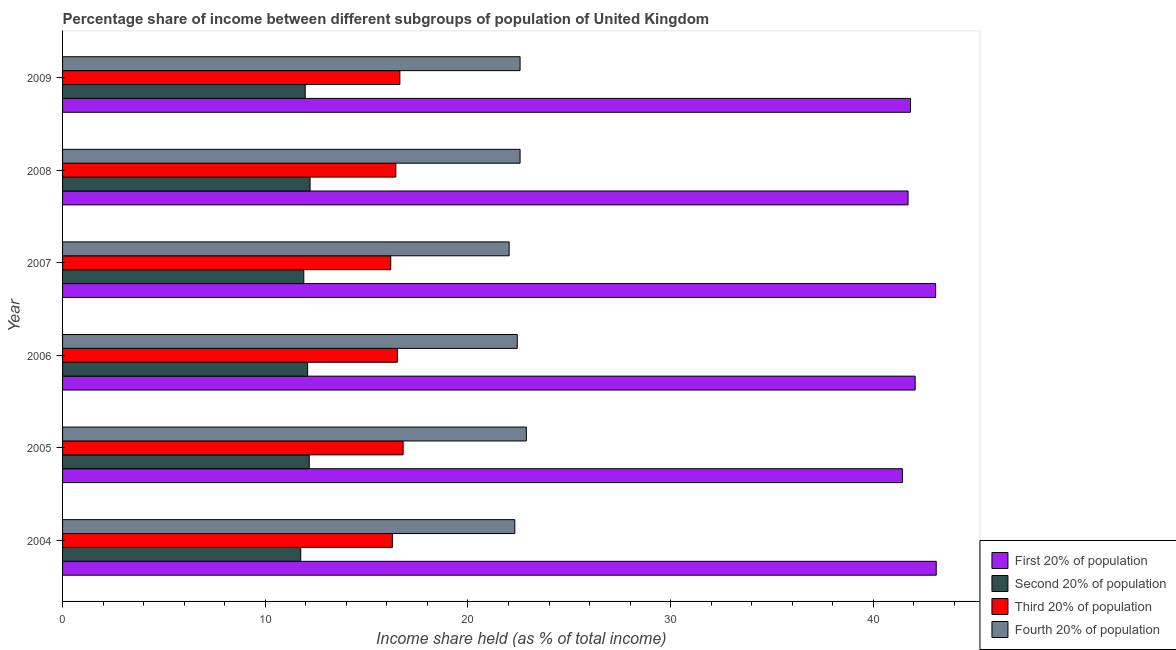Are the number of bars per tick equal to the number of legend labels?
Make the answer very short. Yes. What is the share of the income held by second 20% of the population in 2007?
Your answer should be very brief. 11.9. Across all years, what is the maximum share of the income held by second 20% of the population?
Your answer should be very brief. 12.21. Across all years, what is the minimum share of the income held by first 20% of the population?
Give a very brief answer. 41.43. In which year was the share of the income held by fourth 20% of the population maximum?
Your answer should be compact. 2005. In which year was the share of the income held by fourth 20% of the population minimum?
Offer a very short reply. 2007. What is the total share of the income held by third 20% of the population in the graph?
Offer a terse response. 98.86. What is the difference between the share of the income held by third 20% of the population in 2005 and that in 2007?
Ensure brevity in your answer.  0.61. What is the difference between the share of the income held by first 20% of the population in 2009 and the share of the income held by fourth 20% of the population in 2007?
Give a very brief answer. 19.8. What is the average share of the income held by fourth 20% of the population per year?
Offer a terse response. 22.46. In how many years, is the share of the income held by fourth 20% of the population greater than 34 %?
Provide a succinct answer. 0. What is the ratio of the share of the income held by third 20% of the population in 2006 to that in 2007?
Provide a short and direct response. 1.02. Is the share of the income held by fourth 20% of the population in 2006 less than that in 2007?
Provide a succinct answer. No. What is the difference between the highest and the second highest share of the income held by fourth 20% of the population?
Make the answer very short. 0.31. In how many years, is the share of the income held by third 20% of the population greater than the average share of the income held by third 20% of the population taken over all years?
Ensure brevity in your answer.  3. Is the sum of the share of the income held by fourth 20% of the population in 2005 and 2008 greater than the maximum share of the income held by first 20% of the population across all years?
Keep it short and to the point. Yes. Is it the case that in every year, the sum of the share of the income held by third 20% of the population and share of the income held by first 20% of the population is greater than the sum of share of the income held by second 20% of the population and share of the income held by fourth 20% of the population?
Your answer should be compact. Yes. What does the 4th bar from the top in 2006 represents?
Ensure brevity in your answer.  First 20% of population. What does the 2nd bar from the bottom in 2009 represents?
Make the answer very short. Second 20% of population. Is it the case that in every year, the sum of the share of the income held by first 20% of the population and share of the income held by second 20% of the population is greater than the share of the income held by third 20% of the population?
Offer a terse response. Yes. How many bars are there?
Provide a short and direct response. 24. Are all the bars in the graph horizontal?
Your response must be concise. Yes. How many years are there in the graph?
Your answer should be very brief. 6. Are the values on the major ticks of X-axis written in scientific E-notation?
Offer a very short reply. No. Does the graph contain grids?
Make the answer very short. No. Where does the legend appear in the graph?
Offer a terse response. Bottom right. How many legend labels are there?
Give a very brief answer. 4. What is the title of the graph?
Your answer should be very brief. Percentage share of income between different subgroups of population of United Kingdom. What is the label or title of the X-axis?
Your answer should be compact. Income share held (as % of total income). What is the label or title of the Y-axis?
Offer a terse response. Year. What is the Income share held (as % of total income) in First 20% of population in 2004?
Make the answer very short. 43.1. What is the Income share held (as % of total income) of Second 20% of population in 2004?
Make the answer very short. 11.75. What is the Income share held (as % of total income) in Third 20% of population in 2004?
Make the answer very short. 16.27. What is the Income share held (as % of total income) of Fourth 20% of population in 2004?
Give a very brief answer. 22.31. What is the Income share held (as % of total income) of First 20% of population in 2005?
Offer a terse response. 41.43. What is the Income share held (as % of total income) of Second 20% of population in 2005?
Give a very brief answer. 12.17. What is the Income share held (as % of total income) of Fourth 20% of population in 2005?
Your response must be concise. 22.88. What is the Income share held (as % of total income) of First 20% of population in 2006?
Give a very brief answer. 42.06. What is the Income share held (as % of total income) in Second 20% of population in 2006?
Ensure brevity in your answer.  12.09. What is the Income share held (as % of total income) in Third 20% of population in 2006?
Offer a terse response. 16.52. What is the Income share held (as % of total income) in Fourth 20% of population in 2006?
Offer a very short reply. 22.43. What is the Income share held (as % of total income) in First 20% of population in 2007?
Give a very brief answer. 43.07. What is the Income share held (as % of total income) in Second 20% of population in 2007?
Offer a terse response. 11.9. What is the Income share held (as % of total income) in Third 20% of population in 2007?
Give a very brief answer. 16.19. What is the Income share held (as % of total income) of Fourth 20% of population in 2007?
Ensure brevity in your answer.  22.03. What is the Income share held (as % of total income) of First 20% of population in 2008?
Offer a terse response. 41.71. What is the Income share held (as % of total income) in Second 20% of population in 2008?
Make the answer very short. 12.21. What is the Income share held (as % of total income) of Third 20% of population in 2008?
Your answer should be compact. 16.44. What is the Income share held (as % of total income) of Fourth 20% of population in 2008?
Offer a terse response. 22.57. What is the Income share held (as % of total income) of First 20% of population in 2009?
Your answer should be compact. 41.83. What is the Income share held (as % of total income) in Second 20% of population in 2009?
Offer a terse response. 11.97. What is the Income share held (as % of total income) in Third 20% of population in 2009?
Give a very brief answer. 16.64. What is the Income share held (as % of total income) of Fourth 20% of population in 2009?
Provide a short and direct response. 22.57. Across all years, what is the maximum Income share held (as % of total income) of First 20% of population?
Your response must be concise. 43.1. Across all years, what is the maximum Income share held (as % of total income) of Second 20% of population?
Give a very brief answer. 12.21. Across all years, what is the maximum Income share held (as % of total income) in Fourth 20% of population?
Provide a short and direct response. 22.88. Across all years, what is the minimum Income share held (as % of total income) of First 20% of population?
Offer a terse response. 41.43. Across all years, what is the minimum Income share held (as % of total income) in Second 20% of population?
Provide a succinct answer. 11.75. Across all years, what is the minimum Income share held (as % of total income) in Third 20% of population?
Your answer should be very brief. 16.19. Across all years, what is the minimum Income share held (as % of total income) of Fourth 20% of population?
Your answer should be very brief. 22.03. What is the total Income share held (as % of total income) of First 20% of population in the graph?
Give a very brief answer. 253.2. What is the total Income share held (as % of total income) in Second 20% of population in the graph?
Provide a succinct answer. 72.09. What is the total Income share held (as % of total income) in Third 20% of population in the graph?
Keep it short and to the point. 98.86. What is the total Income share held (as % of total income) in Fourth 20% of population in the graph?
Your answer should be very brief. 134.79. What is the difference between the Income share held (as % of total income) of First 20% of population in 2004 and that in 2005?
Offer a very short reply. 1.67. What is the difference between the Income share held (as % of total income) in Second 20% of population in 2004 and that in 2005?
Provide a succinct answer. -0.42. What is the difference between the Income share held (as % of total income) of Third 20% of population in 2004 and that in 2005?
Provide a succinct answer. -0.53. What is the difference between the Income share held (as % of total income) in Fourth 20% of population in 2004 and that in 2005?
Offer a very short reply. -0.57. What is the difference between the Income share held (as % of total income) of First 20% of population in 2004 and that in 2006?
Offer a terse response. 1.04. What is the difference between the Income share held (as % of total income) in Second 20% of population in 2004 and that in 2006?
Your response must be concise. -0.34. What is the difference between the Income share held (as % of total income) of Third 20% of population in 2004 and that in 2006?
Offer a very short reply. -0.25. What is the difference between the Income share held (as % of total income) in Fourth 20% of population in 2004 and that in 2006?
Offer a terse response. -0.12. What is the difference between the Income share held (as % of total income) in Second 20% of population in 2004 and that in 2007?
Offer a very short reply. -0.15. What is the difference between the Income share held (as % of total income) of Fourth 20% of population in 2004 and that in 2007?
Offer a very short reply. 0.28. What is the difference between the Income share held (as % of total income) of First 20% of population in 2004 and that in 2008?
Keep it short and to the point. 1.39. What is the difference between the Income share held (as % of total income) of Second 20% of population in 2004 and that in 2008?
Make the answer very short. -0.46. What is the difference between the Income share held (as % of total income) in Third 20% of population in 2004 and that in 2008?
Make the answer very short. -0.17. What is the difference between the Income share held (as % of total income) of Fourth 20% of population in 2004 and that in 2008?
Ensure brevity in your answer.  -0.26. What is the difference between the Income share held (as % of total income) of First 20% of population in 2004 and that in 2009?
Give a very brief answer. 1.27. What is the difference between the Income share held (as % of total income) of Second 20% of population in 2004 and that in 2009?
Make the answer very short. -0.22. What is the difference between the Income share held (as % of total income) in Third 20% of population in 2004 and that in 2009?
Offer a terse response. -0.37. What is the difference between the Income share held (as % of total income) of Fourth 20% of population in 2004 and that in 2009?
Your answer should be very brief. -0.26. What is the difference between the Income share held (as % of total income) in First 20% of population in 2005 and that in 2006?
Make the answer very short. -0.63. What is the difference between the Income share held (as % of total income) in Third 20% of population in 2005 and that in 2006?
Keep it short and to the point. 0.28. What is the difference between the Income share held (as % of total income) of Fourth 20% of population in 2005 and that in 2006?
Provide a short and direct response. 0.45. What is the difference between the Income share held (as % of total income) in First 20% of population in 2005 and that in 2007?
Make the answer very short. -1.64. What is the difference between the Income share held (as % of total income) in Second 20% of population in 2005 and that in 2007?
Give a very brief answer. 0.27. What is the difference between the Income share held (as % of total income) of Third 20% of population in 2005 and that in 2007?
Keep it short and to the point. 0.61. What is the difference between the Income share held (as % of total income) in Fourth 20% of population in 2005 and that in 2007?
Offer a terse response. 0.85. What is the difference between the Income share held (as % of total income) of First 20% of population in 2005 and that in 2008?
Offer a very short reply. -0.28. What is the difference between the Income share held (as % of total income) of Second 20% of population in 2005 and that in 2008?
Offer a very short reply. -0.04. What is the difference between the Income share held (as % of total income) in Third 20% of population in 2005 and that in 2008?
Provide a short and direct response. 0.36. What is the difference between the Income share held (as % of total income) in Fourth 20% of population in 2005 and that in 2008?
Give a very brief answer. 0.31. What is the difference between the Income share held (as % of total income) of First 20% of population in 2005 and that in 2009?
Offer a terse response. -0.4. What is the difference between the Income share held (as % of total income) in Third 20% of population in 2005 and that in 2009?
Give a very brief answer. 0.16. What is the difference between the Income share held (as % of total income) in Fourth 20% of population in 2005 and that in 2009?
Provide a succinct answer. 0.31. What is the difference between the Income share held (as % of total income) of First 20% of population in 2006 and that in 2007?
Ensure brevity in your answer.  -1.01. What is the difference between the Income share held (as % of total income) of Second 20% of population in 2006 and that in 2007?
Your answer should be very brief. 0.19. What is the difference between the Income share held (as % of total income) in Third 20% of population in 2006 and that in 2007?
Your answer should be very brief. 0.33. What is the difference between the Income share held (as % of total income) in Fourth 20% of population in 2006 and that in 2007?
Make the answer very short. 0.4. What is the difference between the Income share held (as % of total income) of First 20% of population in 2006 and that in 2008?
Give a very brief answer. 0.35. What is the difference between the Income share held (as % of total income) of Second 20% of population in 2006 and that in 2008?
Provide a short and direct response. -0.12. What is the difference between the Income share held (as % of total income) in Third 20% of population in 2006 and that in 2008?
Offer a terse response. 0.08. What is the difference between the Income share held (as % of total income) of Fourth 20% of population in 2006 and that in 2008?
Ensure brevity in your answer.  -0.14. What is the difference between the Income share held (as % of total income) in First 20% of population in 2006 and that in 2009?
Offer a very short reply. 0.23. What is the difference between the Income share held (as % of total income) of Second 20% of population in 2006 and that in 2009?
Give a very brief answer. 0.12. What is the difference between the Income share held (as % of total income) of Third 20% of population in 2006 and that in 2009?
Keep it short and to the point. -0.12. What is the difference between the Income share held (as % of total income) of Fourth 20% of population in 2006 and that in 2009?
Your answer should be compact. -0.14. What is the difference between the Income share held (as % of total income) in First 20% of population in 2007 and that in 2008?
Make the answer very short. 1.36. What is the difference between the Income share held (as % of total income) in Second 20% of population in 2007 and that in 2008?
Offer a terse response. -0.31. What is the difference between the Income share held (as % of total income) of Fourth 20% of population in 2007 and that in 2008?
Your answer should be compact. -0.54. What is the difference between the Income share held (as % of total income) in First 20% of population in 2007 and that in 2009?
Your response must be concise. 1.24. What is the difference between the Income share held (as % of total income) of Second 20% of population in 2007 and that in 2009?
Keep it short and to the point. -0.07. What is the difference between the Income share held (as % of total income) in Third 20% of population in 2007 and that in 2009?
Provide a short and direct response. -0.45. What is the difference between the Income share held (as % of total income) in Fourth 20% of population in 2007 and that in 2009?
Keep it short and to the point. -0.54. What is the difference between the Income share held (as % of total income) in First 20% of population in 2008 and that in 2009?
Give a very brief answer. -0.12. What is the difference between the Income share held (as % of total income) in Second 20% of population in 2008 and that in 2009?
Ensure brevity in your answer.  0.24. What is the difference between the Income share held (as % of total income) in Third 20% of population in 2008 and that in 2009?
Provide a short and direct response. -0.2. What is the difference between the Income share held (as % of total income) in First 20% of population in 2004 and the Income share held (as % of total income) in Second 20% of population in 2005?
Your response must be concise. 30.93. What is the difference between the Income share held (as % of total income) in First 20% of population in 2004 and the Income share held (as % of total income) in Third 20% of population in 2005?
Your answer should be very brief. 26.3. What is the difference between the Income share held (as % of total income) in First 20% of population in 2004 and the Income share held (as % of total income) in Fourth 20% of population in 2005?
Your answer should be very brief. 20.22. What is the difference between the Income share held (as % of total income) in Second 20% of population in 2004 and the Income share held (as % of total income) in Third 20% of population in 2005?
Offer a terse response. -5.05. What is the difference between the Income share held (as % of total income) of Second 20% of population in 2004 and the Income share held (as % of total income) of Fourth 20% of population in 2005?
Keep it short and to the point. -11.13. What is the difference between the Income share held (as % of total income) in Third 20% of population in 2004 and the Income share held (as % of total income) in Fourth 20% of population in 2005?
Your answer should be very brief. -6.61. What is the difference between the Income share held (as % of total income) in First 20% of population in 2004 and the Income share held (as % of total income) in Second 20% of population in 2006?
Give a very brief answer. 31.01. What is the difference between the Income share held (as % of total income) of First 20% of population in 2004 and the Income share held (as % of total income) of Third 20% of population in 2006?
Give a very brief answer. 26.58. What is the difference between the Income share held (as % of total income) of First 20% of population in 2004 and the Income share held (as % of total income) of Fourth 20% of population in 2006?
Your answer should be compact. 20.67. What is the difference between the Income share held (as % of total income) of Second 20% of population in 2004 and the Income share held (as % of total income) of Third 20% of population in 2006?
Give a very brief answer. -4.77. What is the difference between the Income share held (as % of total income) of Second 20% of population in 2004 and the Income share held (as % of total income) of Fourth 20% of population in 2006?
Your answer should be very brief. -10.68. What is the difference between the Income share held (as % of total income) in Third 20% of population in 2004 and the Income share held (as % of total income) in Fourth 20% of population in 2006?
Keep it short and to the point. -6.16. What is the difference between the Income share held (as % of total income) in First 20% of population in 2004 and the Income share held (as % of total income) in Second 20% of population in 2007?
Provide a succinct answer. 31.2. What is the difference between the Income share held (as % of total income) in First 20% of population in 2004 and the Income share held (as % of total income) in Third 20% of population in 2007?
Give a very brief answer. 26.91. What is the difference between the Income share held (as % of total income) of First 20% of population in 2004 and the Income share held (as % of total income) of Fourth 20% of population in 2007?
Your answer should be very brief. 21.07. What is the difference between the Income share held (as % of total income) in Second 20% of population in 2004 and the Income share held (as % of total income) in Third 20% of population in 2007?
Provide a succinct answer. -4.44. What is the difference between the Income share held (as % of total income) of Second 20% of population in 2004 and the Income share held (as % of total income) of Fourth 20% of population in 2007?
Your answer should be very brief. -10.28. What is the difference between the Income share held (as % of total income) in Third 20% of population in 2004 and the Income share held (as % of total income) in Fourth 20% of population in 2007?
Provide a succinct answer. -5.76. What is the difference between the Income share held (as % of total income) in First 20% of population in 2004 and the Income share held (as % of total income) in Second 20% of population in 2008?
Offer a very short reply. 30.89. What is the difference between the Income share held (as % of total income) in First 20% of population in 2004 and the Income share held (as % of total income) in Third 20% of population in 2008?
Offer a terse response. 26.66. What is the difference between the Income share held (as % of total income) of First 20% of population in 2004 and the Income share held (as % of total income) of Fourth 20% of population in 2008?
Make the answer very short. 20.53. What is the difference between the Income share held (as % of total income) in Second 20% of population in 2004 and the Income share held (as % of total income) in Third 20% of population in 2008?
Offer a terse response. -4.69. What is the difference between the Income share held (as % of total income) in Second 20% of population in 2004 and the Income share held (as % of total income) in Fourth 20% of population in 2008?
Provide a succinct answer. -10.82. What is the difference between the Income share held (as % of total income) in First 20% of population in 2004 and the Income share held (as % of total income) in Second 20% of population in 2009?
Provide a short and direct response. 31.13. What is the difference between the Income share held (as % of total income) of First 20% of population in 2004 and the Income share held (as % of total income) of Third 20% of population in 2009?
Offer a terse response. 26.46. What is the difference between the Income share held (as % of total income) in First 20% of population in 2004 and the Income share held (as % of total income) in Fourth 20% of population in 2009?
Ensure brevity in your answer.  20.53. What is the difference between the Income share held (as % of total income) of Second 20% of population in 2004 and the Income share held (as % of total income) of Third 20% of population in 2009?
Your response must be concise. -4.89. What is the difference between the Income share held (as % of total income) of Second 20% of population in 2004 and the Income share held (as % of total income) of Fourth 20% of population in 2009?
Keep it short and to the point. -10.82. What is the difference between the Income share held (as % of total income) in Third 20% of population in 2004 and the Income share held (as % of total income) in Fourth 20% of population in 2009?
Your answer should be very brief. -6.3. What is the difference between the Income share held (as % of total income) of First 20% of population in 2005 and the Income share held (as % of total income) of Second 20% of population in 2006?
Your answer should be compact. 29.34. What is the difference between the Income share held (as % of total income) of First 20% of population in 2005 and the Income share held (as % of total income) of Third 20% of population in 2006?
Offer a terse response. 24.91. What is the difference between the Income share held (as % of total income) in First 20% of population in 2005 and the Income share held (as % of total income) in Fourth 20% of population in 2006?
Offer a very short reply. 19. What is the difference between the Income share held (as % of total income) in Second 20% of population in 2005 and the Income share held (as % of total income) in Third 20% of population in 2006?
Provide a short and direct response. -4.35. What is the difference between the Income share held (as % of total income) in Second 20% of population in 2005 and the Income share held (as % of total income) in Fourth 20% of population in 2006?
Keep it short and to the point. -10.26. What is the difference between the Income share held (as % of total income) in Third 20% of population in 2005 and the Income share held (as % of total income) in Fourth 20% of population in 2006?
Ensure brevity in your answer.  -5.63. What is the difference between the Income share held (as % of total income) in First 20% of population in 2005 and the Income share held (as % of total income) in Second 20% of population in 2007?
Offer a very short reply. 29.53. What is the difference between the Income share held (as % of total income) of First 20% of population in 2005 and the Income share held (as % of total income) of Third 20% of population in 2007?
Give a very brief answer. 25.24. What is the difference between the Income share held (as % of total income) of First 20% of population in 2005 and the Income share held (as % of total income) of Fourth 20% of population in 2007?
Ensure brevity in your answer.  19.4. What is the difference between the Income share held (as % of total income) in Second 20% of population in 2005 and the Income share held (as % of total income) in Third 20% of population in 2007?
Offer a terse response. -4.02. What is the difference between the Income share held (as % of total income) in Second 20% of population in 2005 and the Income share held (as % of total income) in Fourth 20% of population in 2007?
Offer a very short reply. -9.86. What is the difference between the Income share held (as % of total income) of Third 20% of population in 2005 and the Income share held (as % of total income) of Fourth 20% of population in 2007?
Make the answer very short. -5.23. What is the difference between the Income share held (as % of total income) of First 20% of population in 2005 and the Income share held (as % of total income) of Second 20% of population in 2008?
Provide a succinct answer. 29.22. What is the difference between the Income share held (as % of total income) of First 20% of population in 2005 and the Income share held (as % of total income) of Third 20% of population in 2008?
Ensure brevity in your answer.  24.99. What is the difference between the Income share held (as % of total income) in First 20% of population in 2005 and the Income share held (as % of total income) in Fourth 20% of population in 2008?
Keep it short and to the point. 18.86. What is the difference between the Income share held (as % of total income) of Second 20% of population in 2005 and the Income share held (as % of total income) of Third 20% of population in 2008?
Your answer should be very brief. -4.27. What is the difference between the Income share held (as % of total income) of Second 20% of population in 2005 and the Income share held (as % of total income) of Fourth 20% of population in 2008?
Your answer should be compact. -10.4. What is the difference between the Income share held (as % of total income) of Third 20% of population in 2005 and the Income share held (as % of total income) of Fourth 20% of population in 2008?
Provide a short and direct response. -5.77. What is the difference between the Income share held (as % of total income) in First 20% of population in 2005 and the Income share held (as % of total income) in Second 20% of population in 2009?
Ensure brevity in your answer.  29.46. What is the difference between the Income share held (as % of total income) of First 20% of population in 2005 and the Income share held (as % of total income) of Third 20% of population in 2009?
Offer a terse response. 24.79. What is the difference between the Income share held (as % of total income) of First 20% of population in 2005 and the Income share held (as % of total income) of Fourth 20% of population in 2009?
Your answer should be compact. 18.86. What is the difference between the Income share held (as % of total income) in Second 20% of population in 2005 and the Income share held (as % of total income) in Third 20% of population in 2009?
Make the answer very short. -4.47. What is the difference between the Income share held (as % of total income) in Third 20% of population in 2005 and the Income share held (as % of total income) in Fourth 20% of population in 2009?
Provide a short and direct response. -5.77. What is the difference between the Income share held (as % of total income) in First 20% of population in 2006 and the Income share held (as % of total income) in Second 20% of population in 2007?
Provide a succinct answer. 30.16. What is the difference between the Income share held (as % of total income) of First 20% of population in 2006 and the Income share held (as % of total income) of Third 20% of population in 2007?
Your answer should be very brief. 25.87. What is the difference between the Income share held (as % of total income) of First 20% of population in 2006 and the Income share held (as % of total income) of Fourth 20% of population in 2007?
Your response must be concise. 20.03. What is the difference between the Income share held (as % of total income) in Second 20% of population in 2006 and the Income share held (as % of total income) in Fourth 20% of population in 2007?
Provide a succinct answer. -9.94. What is the difference between the Income share held (as % of total income) in Third 20% of population in 2006 and the Income share held (as % of total income) in Fourth 20% of population in 2007?
Provide a succinct answer. -5.51. What is the difference between the Income share held (as % of total income) of First 20% of population in 2006 and the Income share held (as % of total income) of Second 20% of population in 2008?
Keep it short and to the point. 29.85. What is the difference between the Income share held (as % of total income) of First 20% of population in 2006 and the Income share held (as % of total income) of Third 20% of population in 2008?
Provide a short and direct response. 25.62. What is the difference between the Income share held (as % of total income) in First 20% of population in 2006 and the Income share held (as % of total income) in Fourth 20% of population in 2008?
Give a very brief answer. 19.49. What is the difference between the Income share held (as % of total income) of Second 20% of population in 2006 and the Income share held (as % of total income) of Third 20% of population in 2008?
Your answer should be compact. -4.35. What is the difference between the Income share held (as % of total income) in Second 20% of population in 2006 and the Income share held (as % of total income) in Fourth 20% of population in 2008?
Your answer should be compact. -10.48. What is the difference between the Income share held (as % of total income) in Third 20% of population in 2006 and the Income share held (as % of total income) in Fourth 20% of population in 2008?
Provide a succinct answer. -6.05. What is the difference between the Income share held (as % of total income) of First 20% of population in 2006 and the Income share held (as % of total income) of Second 20% of population in 2009?
Your answer should be compact. 30.09. What is the difference between the Income share held (as % of total income) in First 20% of population in 2006 and the Income share held (as % of total income) in Third 20% of population in 2009?
Ensure brevity in your answer.  25.42. What is the difference between the Income share held (as % of total income) of First 20% of population in 2006 and the Income share held (as % of total income) of Fourth 20% of population in 2009?
Your answer should be compact. 19.49. What is the difference between the Income share held (as % of total income) in Second 20% of population in 2006 and the Income share held (as % of total income) in Third 20% of population in 2009?
Provide a succinct answer. -4.55. What is the difference between the Income share held (as % of total income) in Second 20% of population in 2006 and the Income share held (as % of total income) in Fourth 20% of population in 2009?
Give a very brief answer. -10.48. What is the difference between the Income share held (as % of total income) in Third 20% of population in 2006 and the Income share held (as % of total income) in Fourth 20% of population in 2009?
Offer a very short reply. -6.05. What is the difference between the Income share held (as % of total income) of First 20% of population in 2007 and the Income share held (as % of total income) of Second 20% of population in 2008?
Your answer should be very brief. 30.86. What is the difference between the Income share held (as % of total income) in First 20% of population in 2007 and the Income share held (as % of total income) in Third 20% of population in 2008?
Provide a short and direct response. 26.63. What is the difference between the Income share held (as % of total income) in Second 20% of population in 2007 and the Income share held (as % of total income) in Third 20% of population in 2008?
Provide a succinct answer. -4.54. What is the difference between the Income share held (as % of total income) of Second 20% of population in 2007 and the Income share held (as % of total income) of Fourth 20% of population in 2008?
Your response must be concise. -10.67. What is the difference between the Income share held (as % of total income) in Third 20% of population in 2007 and the Income share held (as % of total income) in Fourth 20% of population in 2008?
Offer a terse response. -6.38. What is the difference between the Income share held (as % of total income) of First 20% of population in 2007 and the Income share held (as % of total income) of Second 20% of population in 2009?
Your response must be concise. 31.1. What is the difference between the Income share held (as % of total income) in First 20% of population in 2007 and the Income share held (as % of total income) in Third 20% of population in 2009?
Offer a terse response. 26.43. What is the difference between the Income share held (as % of total income) in First 20% of population in 2007 and the Income share held (as % of total income) in Fourth 20% of population in 2009?
Your response must be concise. 20.5. What is the difference between the Income share held (as % of total income) in Second 20% of population in 2007 and the Income share held (as % of total income) in Third 20% of population in 2009?
Your answer should be compact. -4.74. What is the difference between the Income share held (as % of total income) in Second 20% of population in 2007 and the Income share held (as % of total income) in Fourth 20% of population in 2009?
Ensure brevity in your answer.  -10.67. What is the difference between the Income share held (as % of total income) in Third 20% of population in 2007 and the Income share held (as % of total income) in Fourth 20% of population in 2009?
Provide a short and direct response. -6.38. What is the difference between the Income share held (as % of total income) of First 20% of population in 2008 and the Income share held (as % of total income) of Second 20% of population in 2009?
Provide a short and direct response. 29.74. What is the difference between the Income share held (as % of total income) in First 20% of population in 2008 and the Income share held (as % of total income) in Third 20% of population in 2009?
Keep it short and to the point. 25.07. What is the difference between the Income share held (as % of total income) in First 20% of population in 2008 and the Income share held (as % of total income) in Fourth 20% of population in 2009?
Your answer should be compact. 19.14. What is the difference between the Income share held (as % of total income) of Second 20% of population in 2008 and the Income share held (as % of total income) of Third 20% of population in 2009?
Offer a terse response. -4.43. What is the difference between the Income share held (as % of total income) of Second 20% of population in 2008 and the Income share held (as % of total income) of Fourth 20% of population in 2009?
Make the answer very short. -10.36. What is the difference between the Income share held (as % of total income) of Third 20% of population in 2008 and the Income share held (as % of total income) of Fourth 20% of population in 2009?
Offer a terse response. -6.13. What is the average Income share held (as % of total income) of First 20% of population per year?
Offer a very short reply. 42.2. What is the average Income share held (as % of total income) of Second 20% of population per year?
Your response must be concise. 12.02. What is the average Income share held (as % of total income) in Third 20% of population per year?
Your answer should be very brief. 16.48. What is the average Income share held (as % of total income) of Fourth 20% of population per year?
Give a very brief answer. 22.46. In the year 2004, what is the difference between the Income share held (as % of total income) in First 20% of population and Income share held (as % of total income) in Second 20% of population?
Ensure brevity in your answer.  31.35. In the year 2004, what is the difference between the Income share held (as % of total income) of First 20% of population and Income share held (as % of total income) of Third 20% of population?
Make the answer very short. 26.83. In the year 2004, what is the difference between the Income share held (as % of total income) in First 20% of population and Income share held (as % of total income) in Fourth 20% of population?
Your answer should be very brief. 20.79. In the year 2004, what is the difference between the Income share held (as % of total income) of Second 20% of population and Income share held (as % of total income) of Third 20% of population?
Your answer should be very brief. -4.52. In the year 2004, what is the difference between the Income share held (as % of total income) in Second 20% of population and Income share held (as % of total income) in Fourth 20% of population?
Ensure brevity in your answer.  -10.56. In the year 2004, what is the difference between the Income share held (as % of total income) in Third 20% of population and Income share held (as % of total income) in Fourth 20% of population?
Keep it short and to the point. -6.04. In the year 2005, what is the difference between the Income share held (as % of total income) in First 20% of population and Income share held (as % of total income) in Second 20% of population?
Make the answer very short. 29.26. In the year 2005, what is the difference between the Income share held (as % of total income) of First 20% of population and Income share held (as % of total income) of Third 20% of population?
Your answer should be very brief. 24.63. In the year 2005, what is the difference between the Income share held (as % of total income) of First 20% of population and Income share held (as % of total income) of Fourth 20% of population?
Ensure brevity in your answer.  18.55. In the year 2005, what is the difference between the Income share held (as % of total income) in Second 20% of population and Income share held (as % of total income) in Third 20% of population?
Ensure brevity in your answer.  -4.63. In the year 2005, what is the difference between the Income share held (as % of total income) of Second 20% of population and Income share held (as % of total income) of Fourth 20% of population?
Your response must be concise. -10.71. In the year 2005, what is the difference between the Income share held (as % of total income) of Third 20% of population and Income share held (as % of total income) of Fourth 20% of population?
Your response must be concise. -6.08. In the year 2006, what is the difference between the Income share held (as % of total income) in First 20% of population and Income share held (as % of total income) in Second 20% of population?
Ensure brevity in your answer.  29.97. In the year 2006, what is the difference between the Income share held (as % of total income) of First 20% of population and Income share held (as % of total income) of Third 20% of population?
Provide a short and direct response. 25.54. In the year 2006, what is the difference between the Income share held (as % of total income) in First 20% of population and Income share held (as % of total income) in Fourth 20% of population?
Offer a very short reply. 19.63. In the year 2006, what is the difference between the Income share held (as % of total income) of Second 20% of population and Income share held (as % of total income) of Third 20% of population?
Offer a terse response. -4.43. In the year 2006, what is the difference between the Income share held (as % of total income) of Second 20% of population and Income share held (as % of total income) of Fourth 20% of population?
Your answer should be compact. -10.34. In the year 2006, what is the difference between the Income share held (as % of total income) of Third 20% of population and Income share held (as % of total income) of Fourth 20% of population?
Your answer should be compact. -5.91. In the year 2007, what is the difference between the Income share held (as % of total income) in First 20% of population and Income share held (as % of total income) in Second 20% of population?
Your answer should be very brief. 31.17. In the year 2007, what is the difference between the Income share held (as % of total income) of First 20% of population and Income share held (as % of total income) of Third 20% of population?
Make the answer very short. 26.88. In the year 2007, what is the difference between the Income share held (as % of total income) in First 20% of population and Income share held (as % of total income) in Fourth 20% of population?
Give a very brief answer. 21.04. In the year 2007, what is the difference between the Income share held (as % of total income) of Second 20% of population and Income share held (as % of total income) of Third 20% of population?
Give a very brief answer. -4.29. In the year 2007, what is the difference between the Income share held (as % of total income) in Second 20% of population and Income share held (as % of total income) in Fourth 20% of population?
Keep it short and to the point. -10.13. In the year 2007, what is the difference between the Income share held (as % of total income) of Third 20% of population and Income share held (as % of total income) of Fourth 20% of population?
Keep it short and to the point. -5.84. In the year 2008, what is the difference between the Income share held (as % of total income) of First 20% of population and Income share held (as % of total income) of Second 20% of population?
Ensure brevity in your answer.  29.5. In the year 2008, what is the difference between the Income share held (as % of total income) of First 20% of population and Income share held (as % of total income) of Third 20% of population?
Make the answer very short. 25.27. In the year 2008, what is the difference between the Income share held (as % of total income) of First 20% of population and Income share held (as % of total income) of Fourth 20% of population?
Offer a very short reply. 19.14. In the year 2008, what is the difference between the Income share held (as % of total income) of Second 20% of population and Income share held (as % of total income) of Third 20% of population?
Keep it short and to the point. -4.23. In the year 2008, what is the difference between the Income share held (as % of total income) of Second 20% of population and Income share held (as % of total income) of Fourth 20% of population?
Your response must be concise. -10.36. In the year 2008, what is the difference between the Income share held (as % of total income) of Third 20% of population and Income share held (as % of total income) of Fourth 20% of population?
Give a very brief answer. -6.13. In the year 2009, what is the difference between the Income share held (as % of total income) in First 20% of population and Income share held (as % of total income) in Second 20% of population?
Keep it short and to the point. 29.86. In the year 2009, what is the difference between the Income share held (as % of total income) in First 20% of population and Income share held (as % of total income) in Third 20% of population?
Ensure brevity in your answer.  25.19. In the year 2009, what is the difference between the Income share held (as % of total income) of First 20% of population and Income share held (as % of total income) of Fourth 20% of population?
Give a very brief answer. 19.26. In the year 2009, what is the difference between the Income share held (as % of total income) in Second 20% of population and Income share held (as % of total income) in Third 20% of population?
Your answer should be compact. -4.67. In the year 2009, what is the difference between the Income share held (as % of total income) of Second 20% of population and Income share held (as % of total income) of Fourth 20% of population?
Provide a short and direct response. -10.6. In the year 2009, what is the difference between the Income share held (as % of total income) of Third 20% of population and Income share held (as % of total income) of Fourth 20% of population?
Provide a succinct answer. -5.93. What is the ratio of the Income share held (as % of total income) in First 20% of population in 2004 to that in 2005?
Your answer should be compact. 1.04. What is the ratio of the Income share held (as % of total income) of Second 20% of population in 2004 to that in 2005?
Your answer should be very brief. 0.97. What is the ratio of the Income share held (as % of total income) of Third 20% of population in 2004 to that in 2005?
Keep it short and to the point. 0.97. What is the ratio of the Income share held (as % of total income) of Fourth 20% of population in 2004 to that in 2005?
Your answer should be very brief. 0.98. What is the ratio of the Income share held (as % of total income) in First 20% of population in 2004 to that in 2006?
Offer a very short reply. 1.02. What is the ratio of the Income share held (as % of total income) in Second 20% of population in 2004 to that in 2006?
Provide a succinct answer. 0.97. What is the ratio of the Income share held (as % of total income) of Third 20% of population in 2004 to that in 2006?
Offer a terse response. 0.98. What is the ratio of the Income share held (as % of total income) of First 20% of population in 2004 to that in 2007?
Provide a succinct answer. 1. What is the ratio of the Income share held (as % of total income) of Second 20% of population in 2004 to that in 2007?
Keep it short and to the point. 0.99. What is the ratio of the Income share held (as % of total income) in Third 20% of population in 2004 to that in 2007?
Your answer should be compact. 1. What is the ratio of the Income share held (as % of total income) in Fourth 20% of population in 2004 to that in 2007?
Ensure brevity in your answer.  1.01. What is the ratio of the Income share held (as % of total income) of Second 20% of population in 2004 to that in 2008?
Provide a succinct answer. 0.96. What is the ratio of the Income share held (as % of total income) of Third 20% of population in 2004 to that in 2008?
Ensure brevity in your answer.  0.99. What is the ratio of the Income share held (as % of total income) in Fourth 20% of population in 2004 to that in 2008?
Offer a very short reply. 0.99. What is the ratio of the Income share held (as % of total income) of First 20% of population in 2004 to that in 2009?
Provide a short and direct response. 1.03. What is the ratio of the Income share held (as % of total income) in Second 20% of population in 2004 to that in 2009?
Ensure brevity in your answer.  0.98. What is the ratio of the Income share held (as % of total income) of Third 20% of population in 2004 to that in 2009?
Your answer should be compact. 0.98. What is the ratio of the Income share held (as % of total income) in Fourth 20% of population in 2004 to that in 2009?
Make the answer very short. 0.99. What is the ratio of the Income share held (as % of total income) in First 20% of population in 2005 to that in 2006?
Offer a very short reply. 0.98. What is the ratio of the Income share held (as % of total income) of Second 20% of population in 2005 to that in 2006?
Make the answer very short. 1.01. What is the ratio of the Income share held (as % of total income) of Third 20% of population in 2005 to that in 2006?
Your answer should be compact. 1.02. What is the ratio of the Income share held (as % of total income) of Fourth 20% of population in 2005 to that in 2006?
Your answer should be very brief. 1.02. What is the ratio of the Income share held (as % of total income) in First 20% of population in 2005 to that in 2007?
Your answer should be compact. 0.96. What is the ratio of the Income share held (as % of total income) of Second 20% of population in 2005 to that in 2007?
Keep it short and to the point. 1.02. What is the ratio of the Income share held (as % of total income) in Third 20% of population in 2005 to that in 2007?
Your response must be concise. 1.04. What is the ratio of the Income share held (as % of total income) in Fourth 20% of population in 2005 to that in 2007?
Keep it short and to the point. 1.04. What is the ratio of the Income share held (as % of total income) in First 20% of population in 2005 to that in 2008?
Offer a terse response. 0.99. What is the ratio of the Income share held (as % of total income) in Third 20% of population in 2005 to that in 2008?
Provide a short and direct response. 1.02. What is the ratio of the Income share held (as % of total income) of Fourth 20% of population in 2005 to that in 2008?
Provide a short and direct response. 1.01. What is the ratio of the Income share held (as % of total income) in Second 20% of population in 2005 to that in 2009?
Provide a succinct answer. 1.02. What is the ratio of the Income share held (as % of total income) of Third 20% of population in 2005 to that in 2009?
Give a very brief answer. 1.01. What is the ratio of the Income share held (as % of total income) of Fourth 20% of population in 2005 to that in 2009?
Make the answer very short. 1.01. What is the ratio of the Income share held (as % of total income) of First 20% of population in 2006 to that in 2007?
Provide a succinct answer. 0.98. What is the ratio of the Income share held (as % of total income) in Second 20% of population in 2006 to that in 2007?
Provide a short and direct response. 1.02. What is the ratio of the Income share held (as % of total income) of Third 20% of population in 2006 to that in 2007?
Provide a succinct answer. 1.02. What is the ratio of the Income share held (as % of total income) of Fourth 20% of population in 2006 to that in 2007?
Keep it short and to the point. 1.02. What is the ratio of the Income share held (as % of total income) in First 20% of population in 2006 to that in 2008?
Give a very brief answer. 1.01. What is the ratio of the Income share held (as % of total income) of Second 20% of population in 2006 to that in 2008?
Make the answer very short. 0.99. What is the ratio of the Income share held (as % of total income) of Fourth 20% of population in 2006 to that in 2008?
Make the answer very short. 0.99. What is the ratio of the Income share held (as % of total income) in Second 20% of population in 2006 to that in 2009?
Your answer should be very brief. 1.01. What is the ratio of the Income share held (as % of total income) of First 20% of population in 2007 to that in 2008?
Keep it short and to the point. 1.03. What is the ratio of the Income share held (as % of total income) in Second 20% of population in 2007 to that in 2008?
Offer a terse response. 0.97. What is the ratio of the Income share held (as % of total income) of Fourth 20% of population in 2007 to that in 2008?
Keep it short and to the point. 0.98. What is the ratio of the Income share held (as % of total income) in First 20% of population in 2007 to that in 2009?
Make the answer very short. 1.03. What is the ratio of the Income share held (as % of total income) in Fourth 20% of population in 2007 to that in 2009?
Provide a succinct answer. 0.98. What is the ratio of the Income share held (as % of total income) in First 20% of population in 2008 to that in 2009?
Keep it short and to the point. 1. What is the ratio of the Income share held (as % of total income) in Second 20% of population in 2008 to that in 2009?
Your response must be concise. 1.02. What is the difference between the highest and the second highest Income share held (as % of total income) in Second 20% of population?
Provide a succinct answer. 0.04. What is the difference between the highest and the second highest Income share held (as % of total income) in Third 20% of population?
Make the answer very short. 0.16. What is the difference between the highest and the second highest Income share held (as % of total income) in Fourth 20% of population?
Your answer should be very brief. 0.31. What is the difference between the highest and the lowest Income share held (as % of total income) in First 20% of population?
Keep it short and to the point. 1.67. What is the difference between the highest and the lowest Income share held (as % of total income) in Second 20% of population?
Make the answer very short. 0.46. What is the difference between the highest and the lowest Income share held (as % of total income) in Third 20% of population?
Your response must be concise. 0.61. 